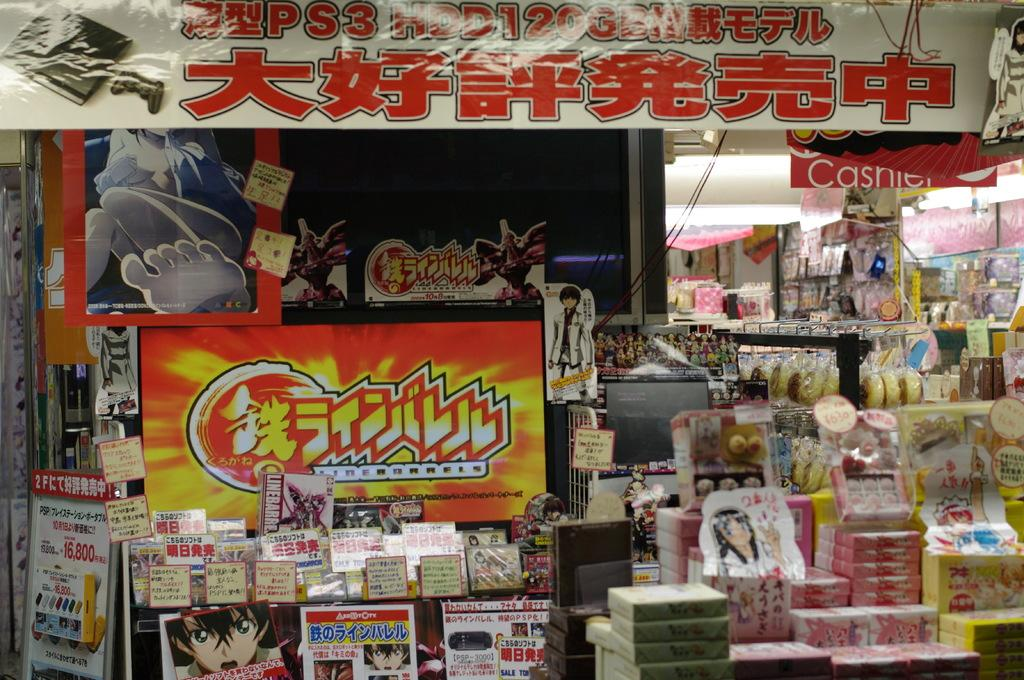What type of establishment is shown in the image? There is a shop in the image. What can be found inside the shop? There are many items kept in the shop. Can you describe any additional features in the image? There is a poster with text on it, and there are lights and cable wires visible. What is the shop owner's deepest desire in the image? There is no information about the shop owner's desires in the image. Can you tell me what the shop owner is thinking while looking at the poster? There is no information about the shop owner's thoughts in the image. 